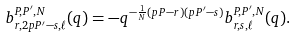<formula> <loc_0><loc_0><loc_500><loc_500>b _ { r , 2 p P ^ { \prime } - s , \ell } ^ { P , P ^ { \prime } , N } ( q ) = - q ^ { - \frac { 1 } { N } ( p P - r ) ( p P ^ { \prime } - s ) } b _ { r , s , \ell } ^ { P , P ^ { \prime } , N } ( q ) .</formula> 